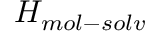Convert formula to latex. <formula><loc_0><loc_0><loc_500><loc_500>H _ { m o l - s o l v }</formula> 